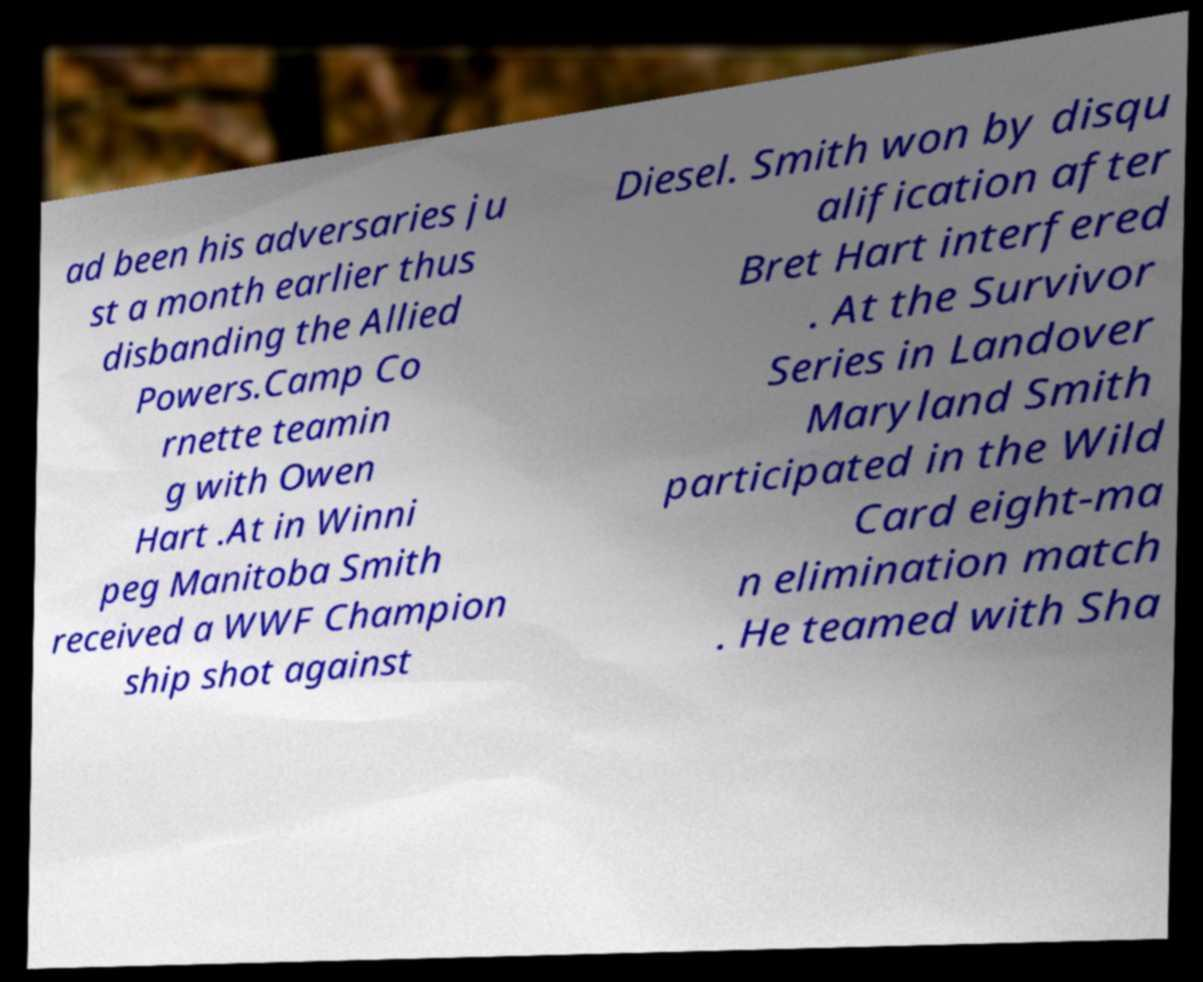Please read and relay the text visible in this image. What does it say? ad been his adversaries ju st a month earlier thus disbanding the Allied Powers.Camp Co rnette teamin g with Owen Hart .At in Winni peg Manitoba Smith received a WWF Champion ship shot against Diesel. Smith won by disqu alification after Bret Hart interfered . At the Survivor Series in Landover Maryland Smith participated in the Wild Card eight-ma n elimination match . He teamed with Sha 